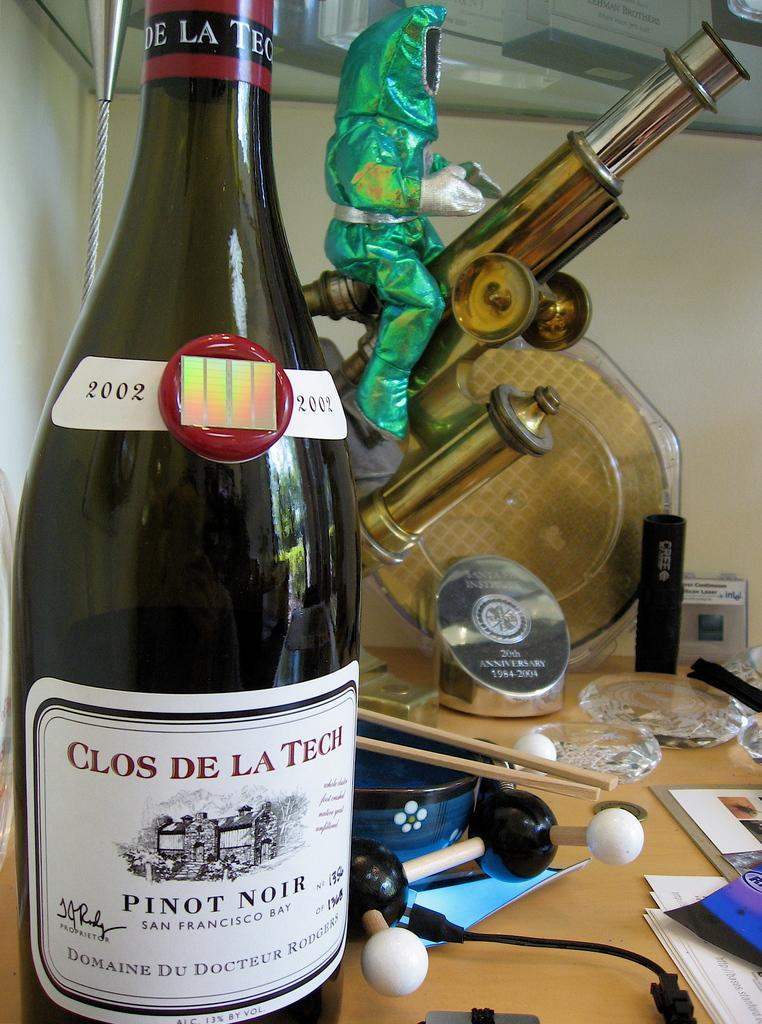<image>
Describe the image concisely. A metallc green figure astride what looks like a telescope and a bottle of wine labelled 2002 